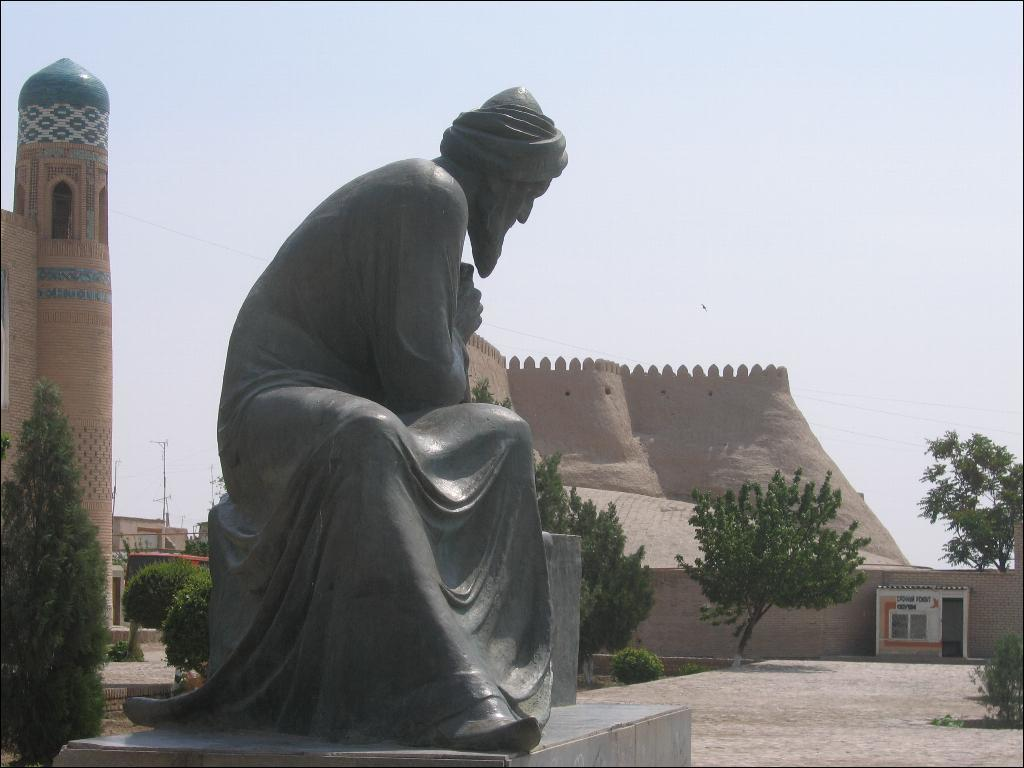What is the main subject of the image? There is a sculpture in the image. What other elements can be seen in the image besides the sculpture? The image contains architectural elements, plants, and a pole. What is visible in the background of the image? The sky is visible in the background of the image. Can you describe the skate trick being performed by the person in the image? There is no person or skate trick present in the image; it features a sculpture, architectural elements, plants, a pole, and the sky. 